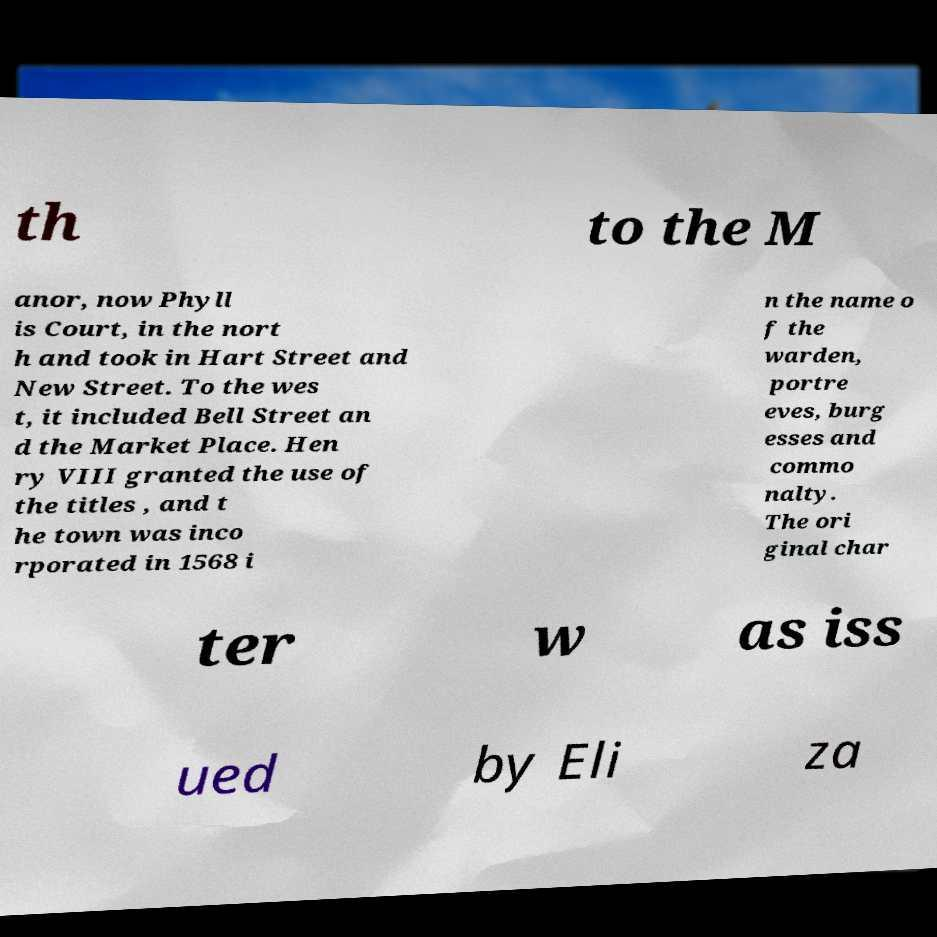Can you accurately transcribe the text from the provided image for me? th to the M anor, now Phyll is Court, in the nort h and took in Hart Street and New Street. To the wes t, it included Bell Street an d the Market Place. Hen ry VIII granted the use of the titles , and t he town was inco rporated in 1568 i n the name o f the warden, portre eves, burg esses and commo nalty. The ori ginal char ter w as iss ued by Eli za 